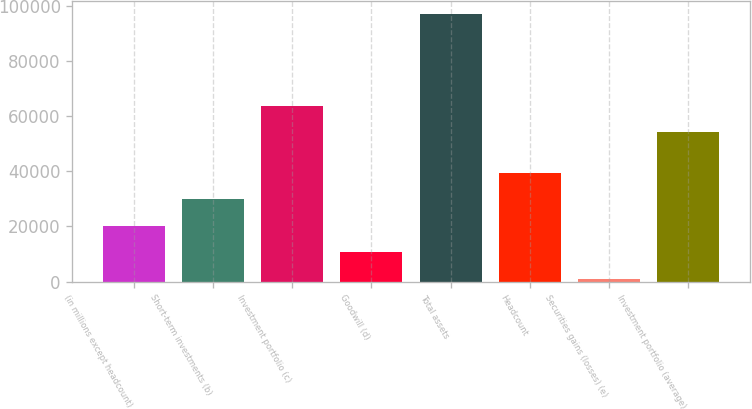<chart> <loc_0><loc_0><loc_500><loc_500><bar_chart><fcel>(in millions except headcount)<fcel>Short-term investments (b)<fcel>Investment portfolio (c)<fcel>Goodwill (d)<fcel>Total assets<fcel>Headcount<fcel>Securities gains (losses) (e)<fcel>Investment portfolio (average)<nl><fcel>20276.2<fcel>29877.8<fcel>63798.6<fcel>10674.6<fcel>97089<fcel>39479.4<fcel>1073<fcel>54197<nl></chart> 